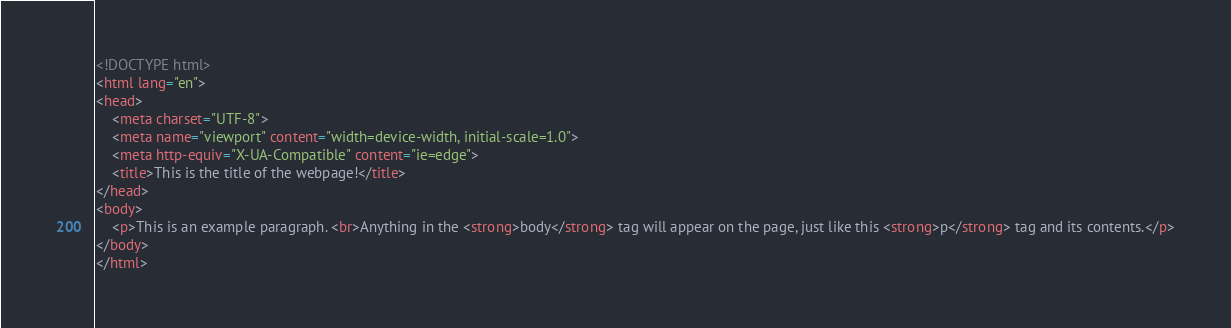Convert code to text. <code><loc_0><loc_0><loc_500><loc_500><_HTML_><!DOCTYPE html>
<html lang="en">
<head>
    <meta charset="UTF-8">
    <meta name="viewport" content="width=device-width, initial-scale=1.0">
    <meta http-equiv="X-UA-Compatible" content="ie=edge">
    <title>This is the title of the webpage!</title>
</head>
<body>
    <p>This is an example paragraph. <br>Anything in the <strong>body</strong> tag will appear on the page, just like this <strong>p</strong> tag and its contents.</p>
</body>
</html>
</code> 